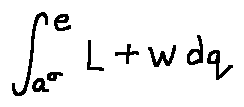Convert formula to latex. <formula><loc_0><loc_0><loc_500><loc_500>\int \lim i t s _ { a ^ { \sigma } } ^ { e } L + w d q</formula> 